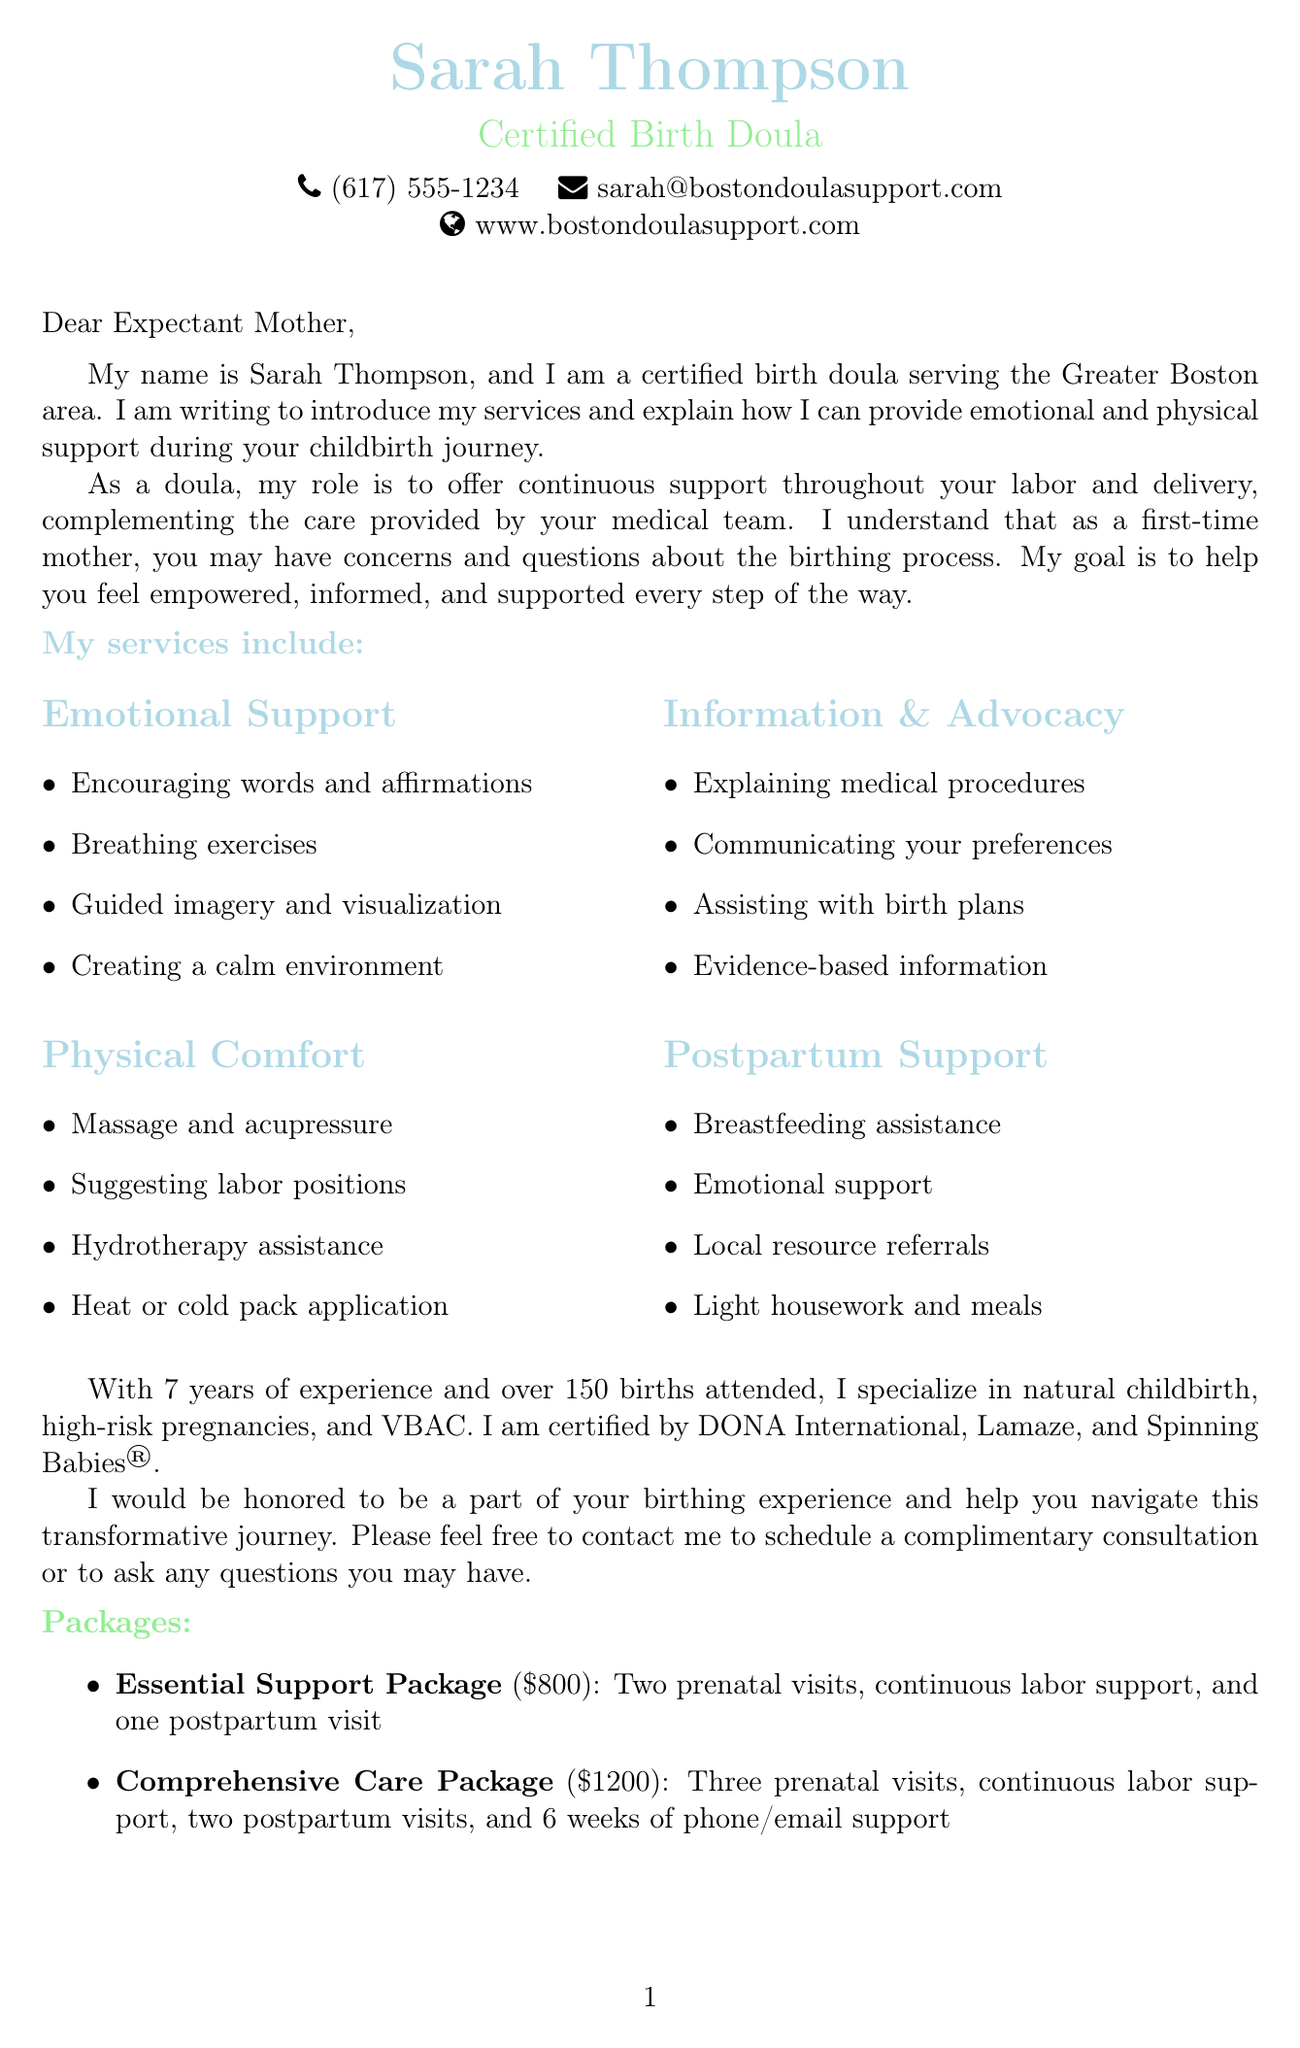What is the name of the doula? The document introduces the doula as Sarah Thompson.
Answer: Sarah Thompson How many years of experience does the doula have? The document states that Sarah has 7 years of experience.
Answer: 7 What are the two packages mentioned? The document lists the "Essential Support Package" and "Comprehensive Care Package."
Answer: Essential Support Package, Comprehensive Care Package What is the price of the Comprehensive Care Package? The document specifies that the price for the Comprehensive Care Package is $1200.
Answer: $1200 What type of childbirth does Sarah specialize in? The document mentions her specialization in natural childbirth.
Answer: Natural childbirth What is one emotional support technique mentioned? The document lists techniques such as encouraging words and positive affirmations.
Answer: Encouraging words and positive affirmations How many births has Sarah attended? The document notes that Sarah has attended over 150 births.
Answer: 150 What is the primary role of a doula? The document describes the doula's role as providing continuous support throughout labor and delivery.
Answer: Continuous support What types of support does the doula offer postpartum? The document details support such as breastfeeding assistance and emotional support during the transition to parenthood.
Answer: Breastfeeding assistance and emotional support 